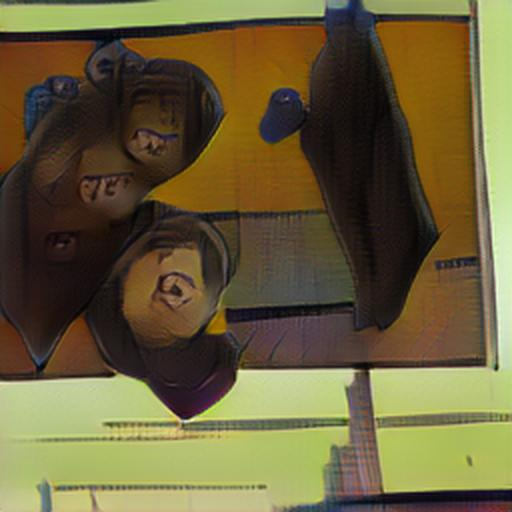How clear is the subject in the image?
A. Not very clear
B. Very clear
C. Extremely clear
D. Clear The clarity of the subject in the image can be considered somewhat compromised due to distortion effects. While the outlines and shapes are discernible, details are obscured, making the view less than ideal. Light and color play a significant role in this image, with various hues juxtaposed against one another, adding to the complexity of the visual experience. Thus, I would classify the clarity as 'Not very clear' on the given scale. 